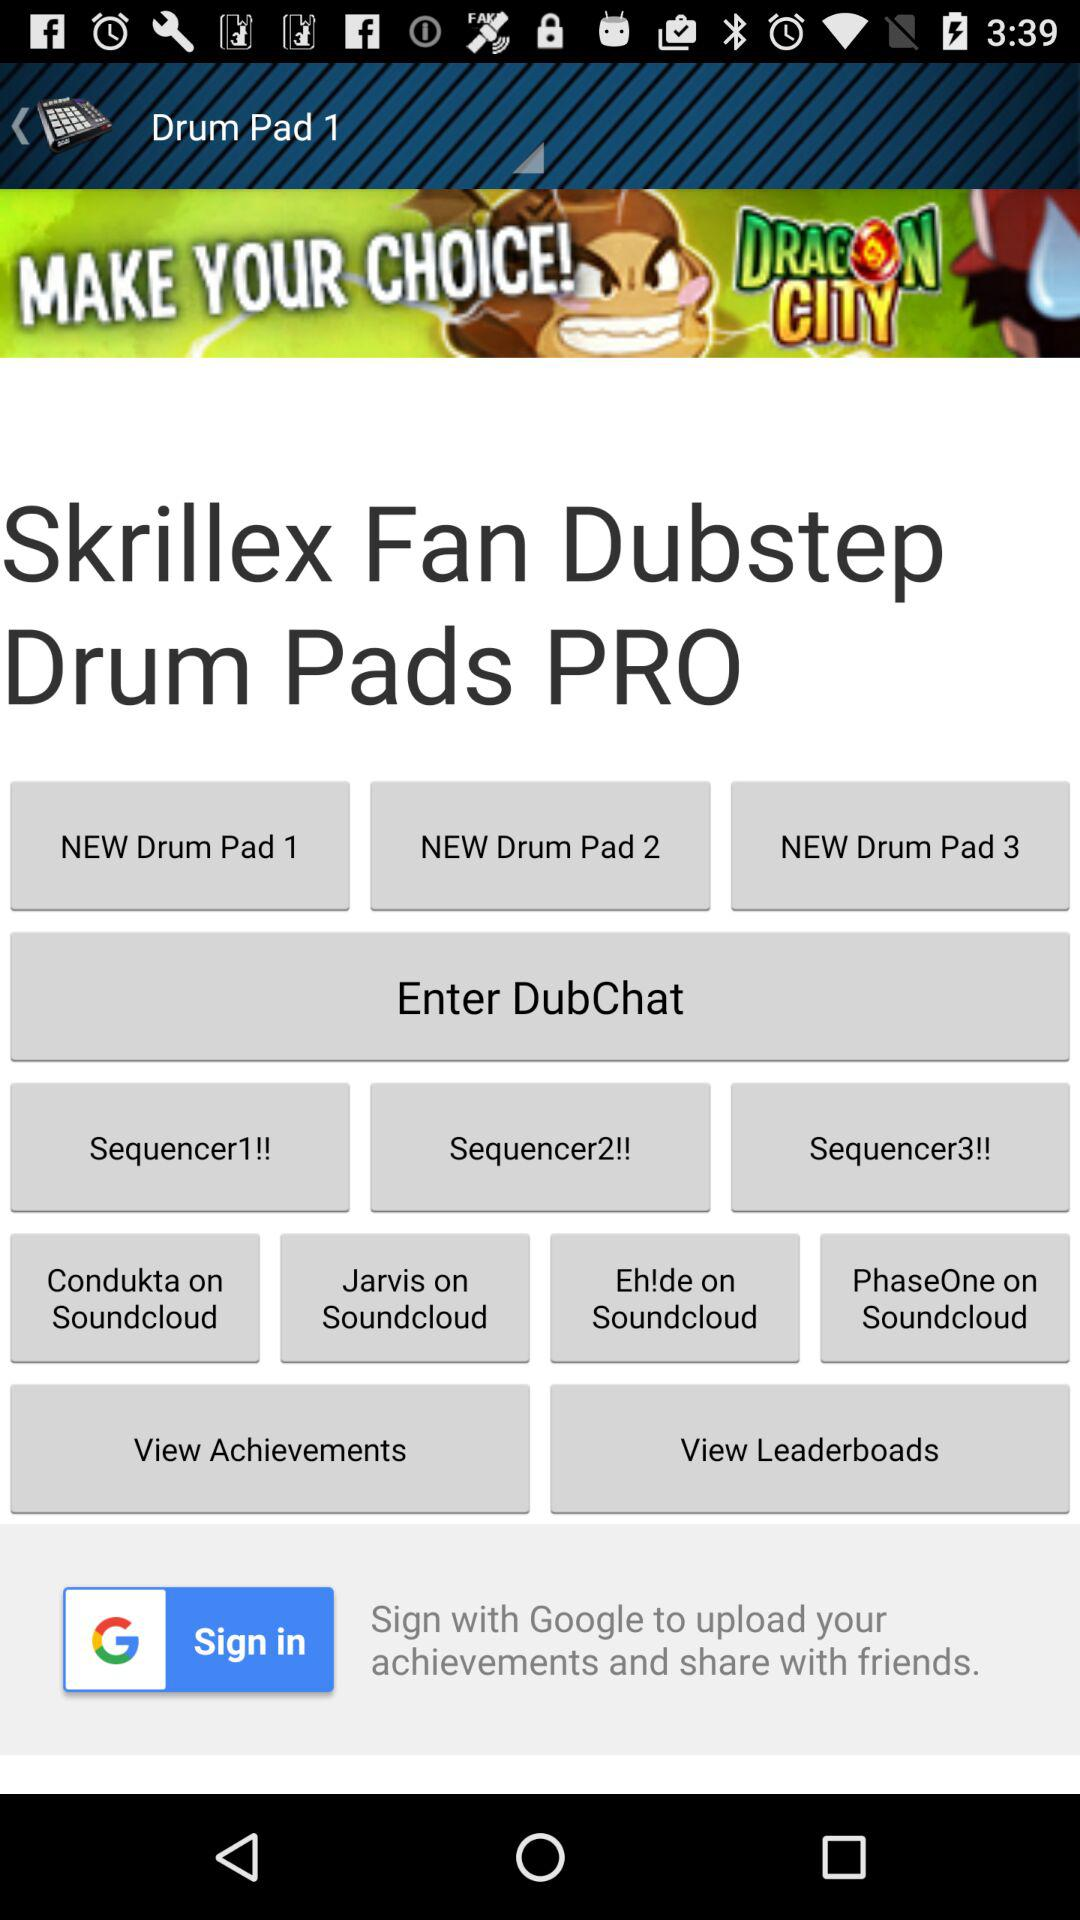What application can be used for signing in? The application that can be used to sign in is "Google". 